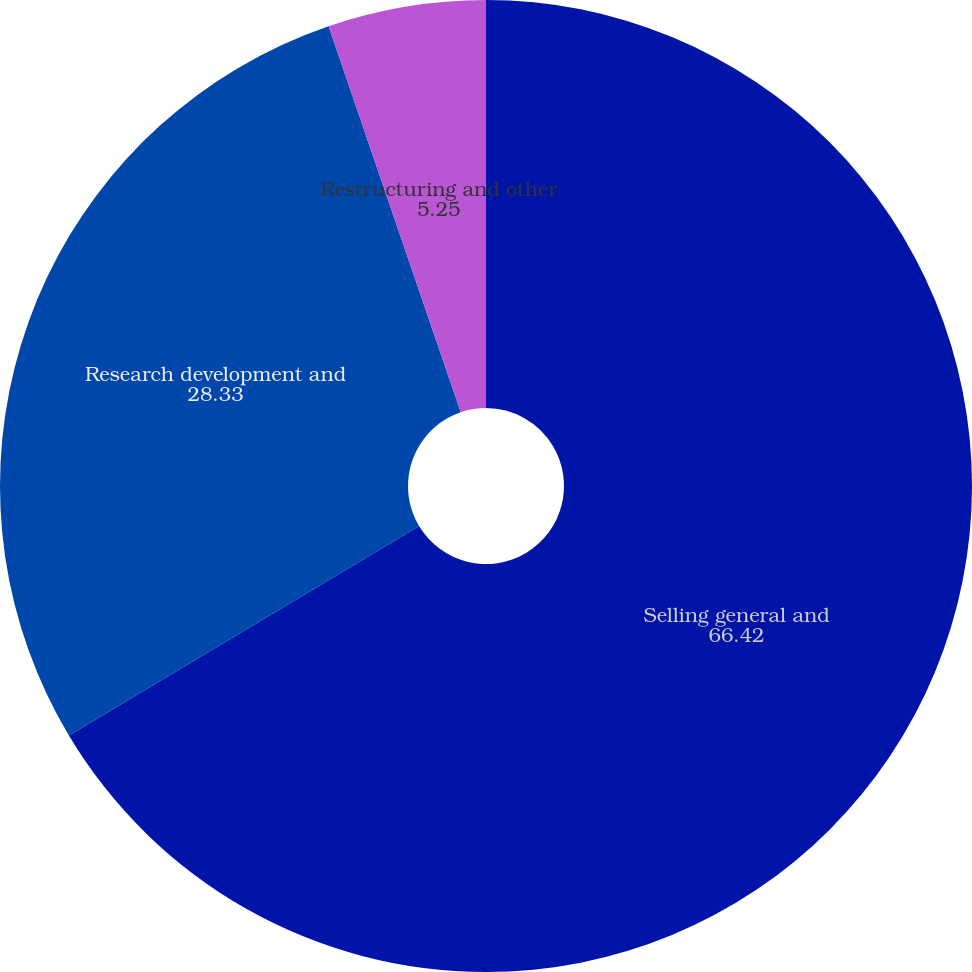Convert chart to OTSL. <chart><loc_0><loc_0><loc_500><loc_500><pie_chart><fcel>Selling general and<fcel>Research development and<fcel>Restructuring and other<nl><fcel>66.42%<fcel>28.33%<fcel>5.25%<nl></chart> 